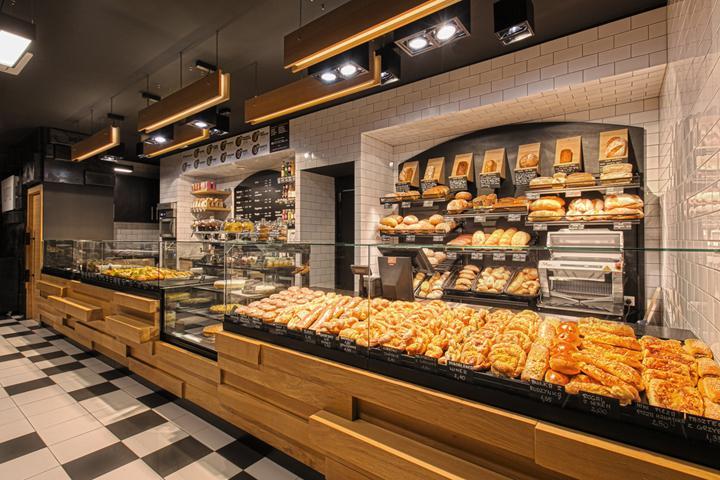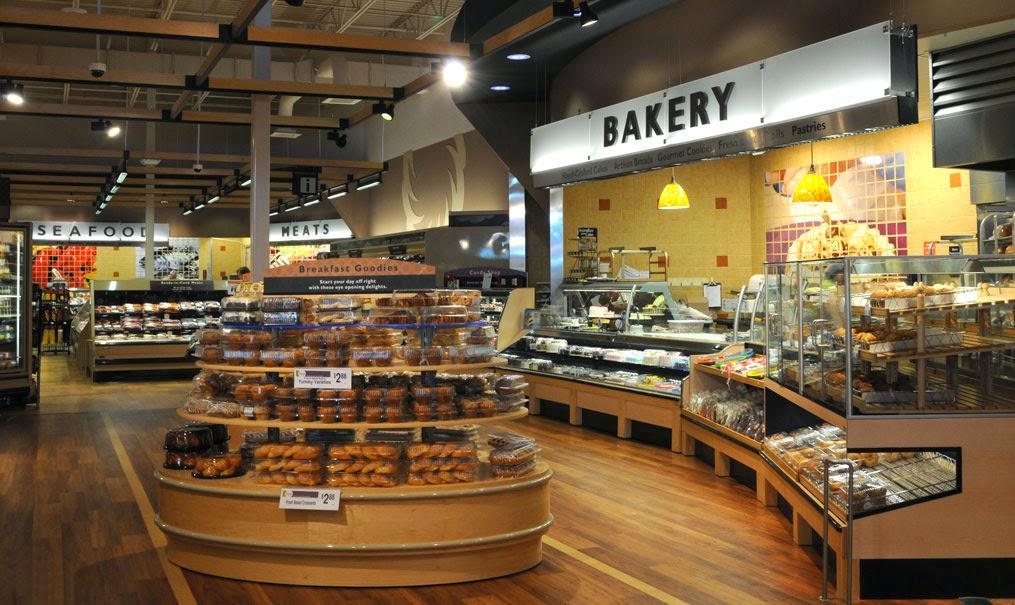The first image is the image on the left, the second image is the image on the right. Examine the images to the left and right. Is the description "there is exactly one person in the image on the right." accurate? Answer yes or no. No. The first image is the image on the left, the second image is the image on the right. Assess this claim about the two images: "An image shows a bakery with a natural tan stone-look floor.". Correct or not? Answer yes or no. No. 